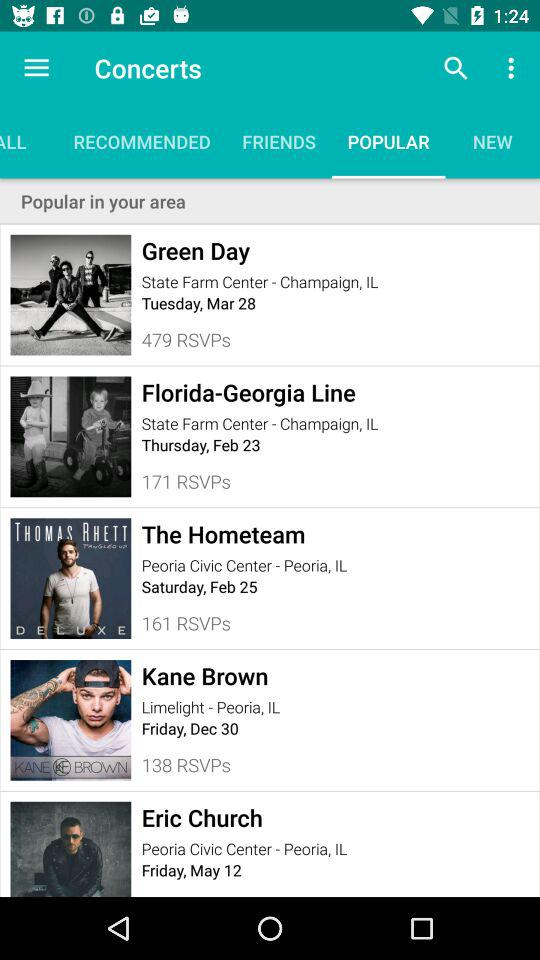How many RSVPs are there for Kane Brown? There are 138 RSVPs for Kane Brown. 